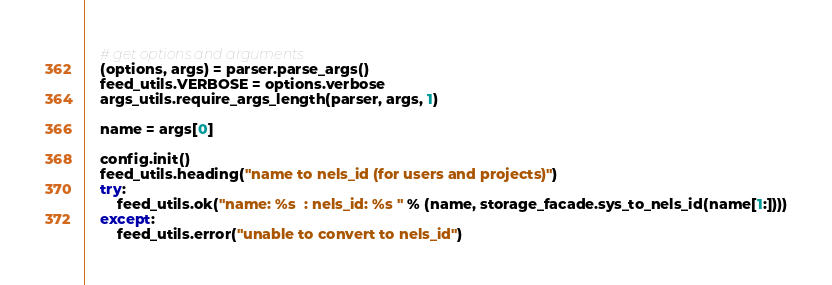<code> <loc_0><loc_0><loc_500><loc_500><_Python_>    # get options and arguments
    (options, args) = parser.parse_args()
    feed_utils.VERBOSE = options.verbose
    args_utils.require_args_length(parser, args, 1)

    name = args[0]

    config.init()
    feed_utils.heading("name to nels_id (for users and projects)")
    try:
        feed_utils.ok("name: %s  : nels_id: %s " % (name, storage_facade.sys_to_nels_id(name[1:])))
    except:
        feed_utils.error("unable to convert to nels_id")
</code> 